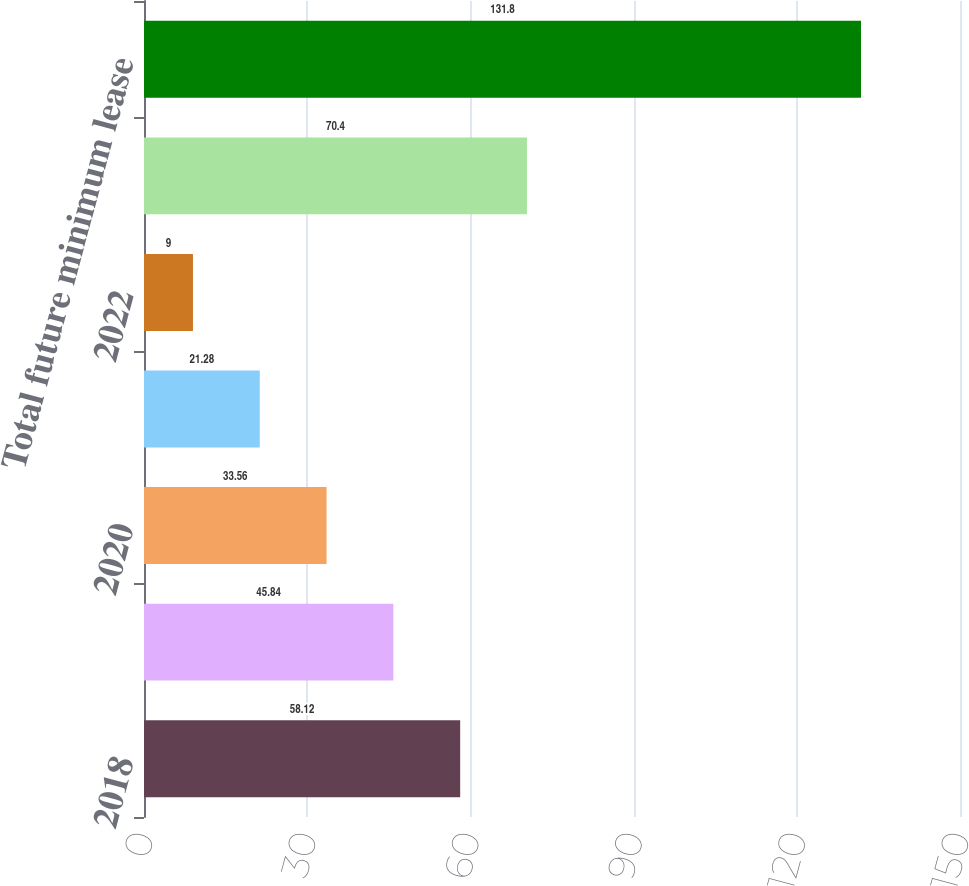Convert chart to OTSL. <chart><loc_0><loc_0><loc_500><loc_500><bar_chart><fcel>2018<fcel>2019<fcel>2020<fcel>2021<fcel>2022<fcel>Thereafter<fcel>Total future minimum lease<nl><fcel>58.12<fcel>45.84<fcel>33.56<fcel>21.28<fcel>9<fcel>70.4<fcel>131.8<nl></chart> 